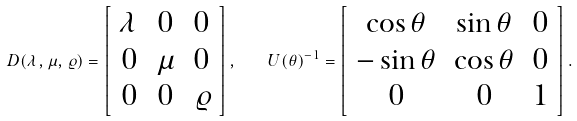<formula> <loc_0><loc_0><loc_500><loc_500>D ( \lambda , \mu , \varrho ) = \left [ \begin{array} { c c c } \lambda & 0 & 0 \\ 0 & \mu & 0 \\ 0 & 0 & \varrho \end{array} \right ] , \quad U ( \theta ) ^ { - 1 } = \left [ \begin{array} { c c c } \cos \theta & \sin \theta & 0 \\ - \sin \theta & \cos \theta & 0 \\ 0 & 0 & 1 \end{array} \right ] .</formula> 